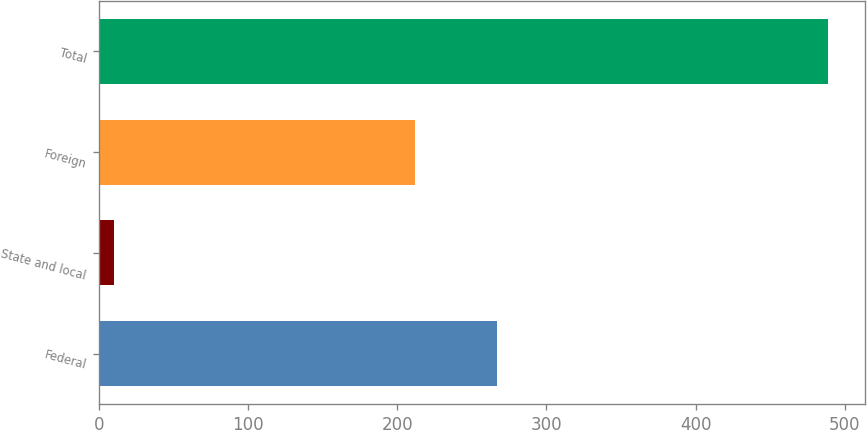<chart> <loc_0><loc_0><loc_500><loc_500><bar_chart><fcel>Federal<fcel>State and local<fcel>Foreign<fcel>Total<nl><fcel>267<fcel>10<fcel>212<fcel>489<nl></chart> 